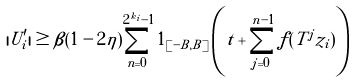Convert formula to latex. <formula><loc_0><loc_0><loc_500><loc_500>| U _ { i } ^ { \prime } | \geq \beta ( 1 - 2 \eta ) \sum _ { n = 0 } ^ { 2 ^ { k _ { i } } - 1 } 1 _ { [ - B , B ] } \left ( t + \sum _ { j = 0 } ^ { n - 1 } f ( T ^ { j } z _ { i } ) \right )</formula> 